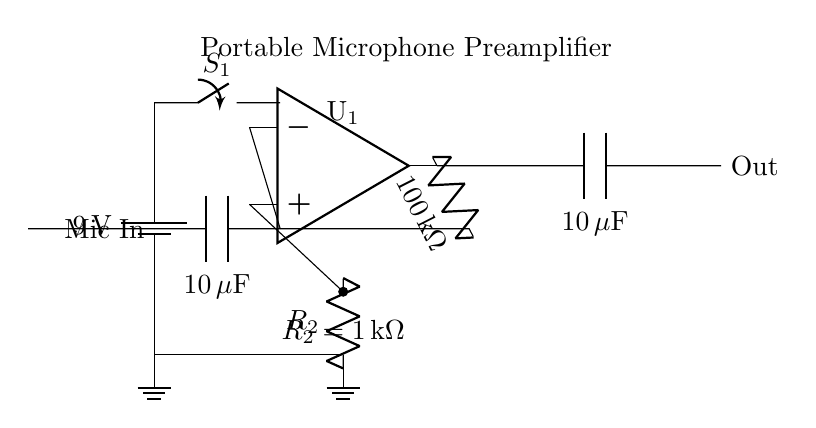What is the power supply voltage of the circuit? The power supply voltage is indicated next to the battery component in the circuit diagram, labeled as 9 volts.
Answer: 9 volts What type of component is U1? The U1 component is labeled as an operational amplifier (op-amp) in the circuit diagram. It is responsible for amplifying the microphone signal.
Answer: Operational amplifier What is the value of the feedback resistor? The feedback resistor, labeled as R_f, is specified with a value of 100 kiloohms in the circuit. This value determines the gain of the op-amp circuit.
Answer: 100 kiloohms Which component is used for signal coupling at the input? The input capacitor, labeled C_1, is used for signal coupling at the microphone input, allowing AC signals to pass while blocking DC.
Answer: Input capacitor How does the output capacitor affect the audio signal? The output capacitor, labeled C_2, allows the audio signal to pass while blocking any DC component, ensuring that only the useful audio signal is transmitted to the output.
Answer: Blocks DC, allows audio What is the input impedance of the circuit? The input impedance can be determined by the combination of the resistor R_2 and the op-amp. Since R_2 is 1 kiloohm, the overall input impedance will be affected by the op-amp properties, but primarily it would include this resistor value.
Answer: 1 kiloohm What function does the switch S1 serve in this circuit? The switch S1 is used to turn the circuit on or off, providing control over the power supply to the rest of the components, including the microphone amplifier.
Answer: Power control 